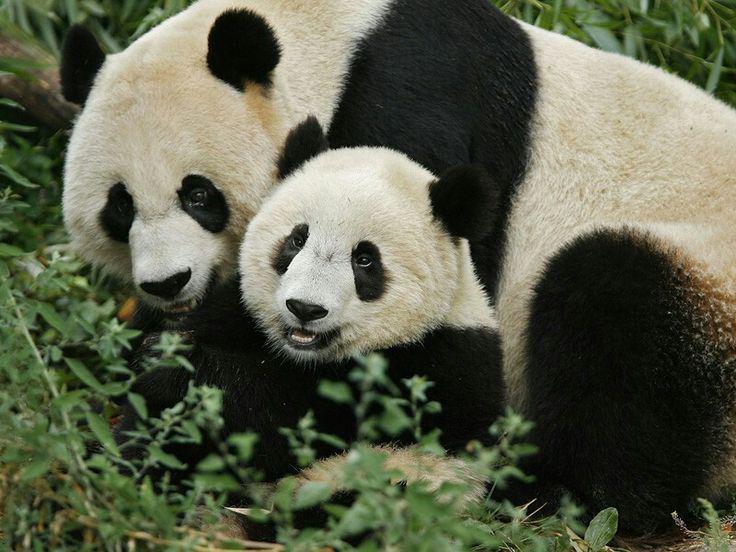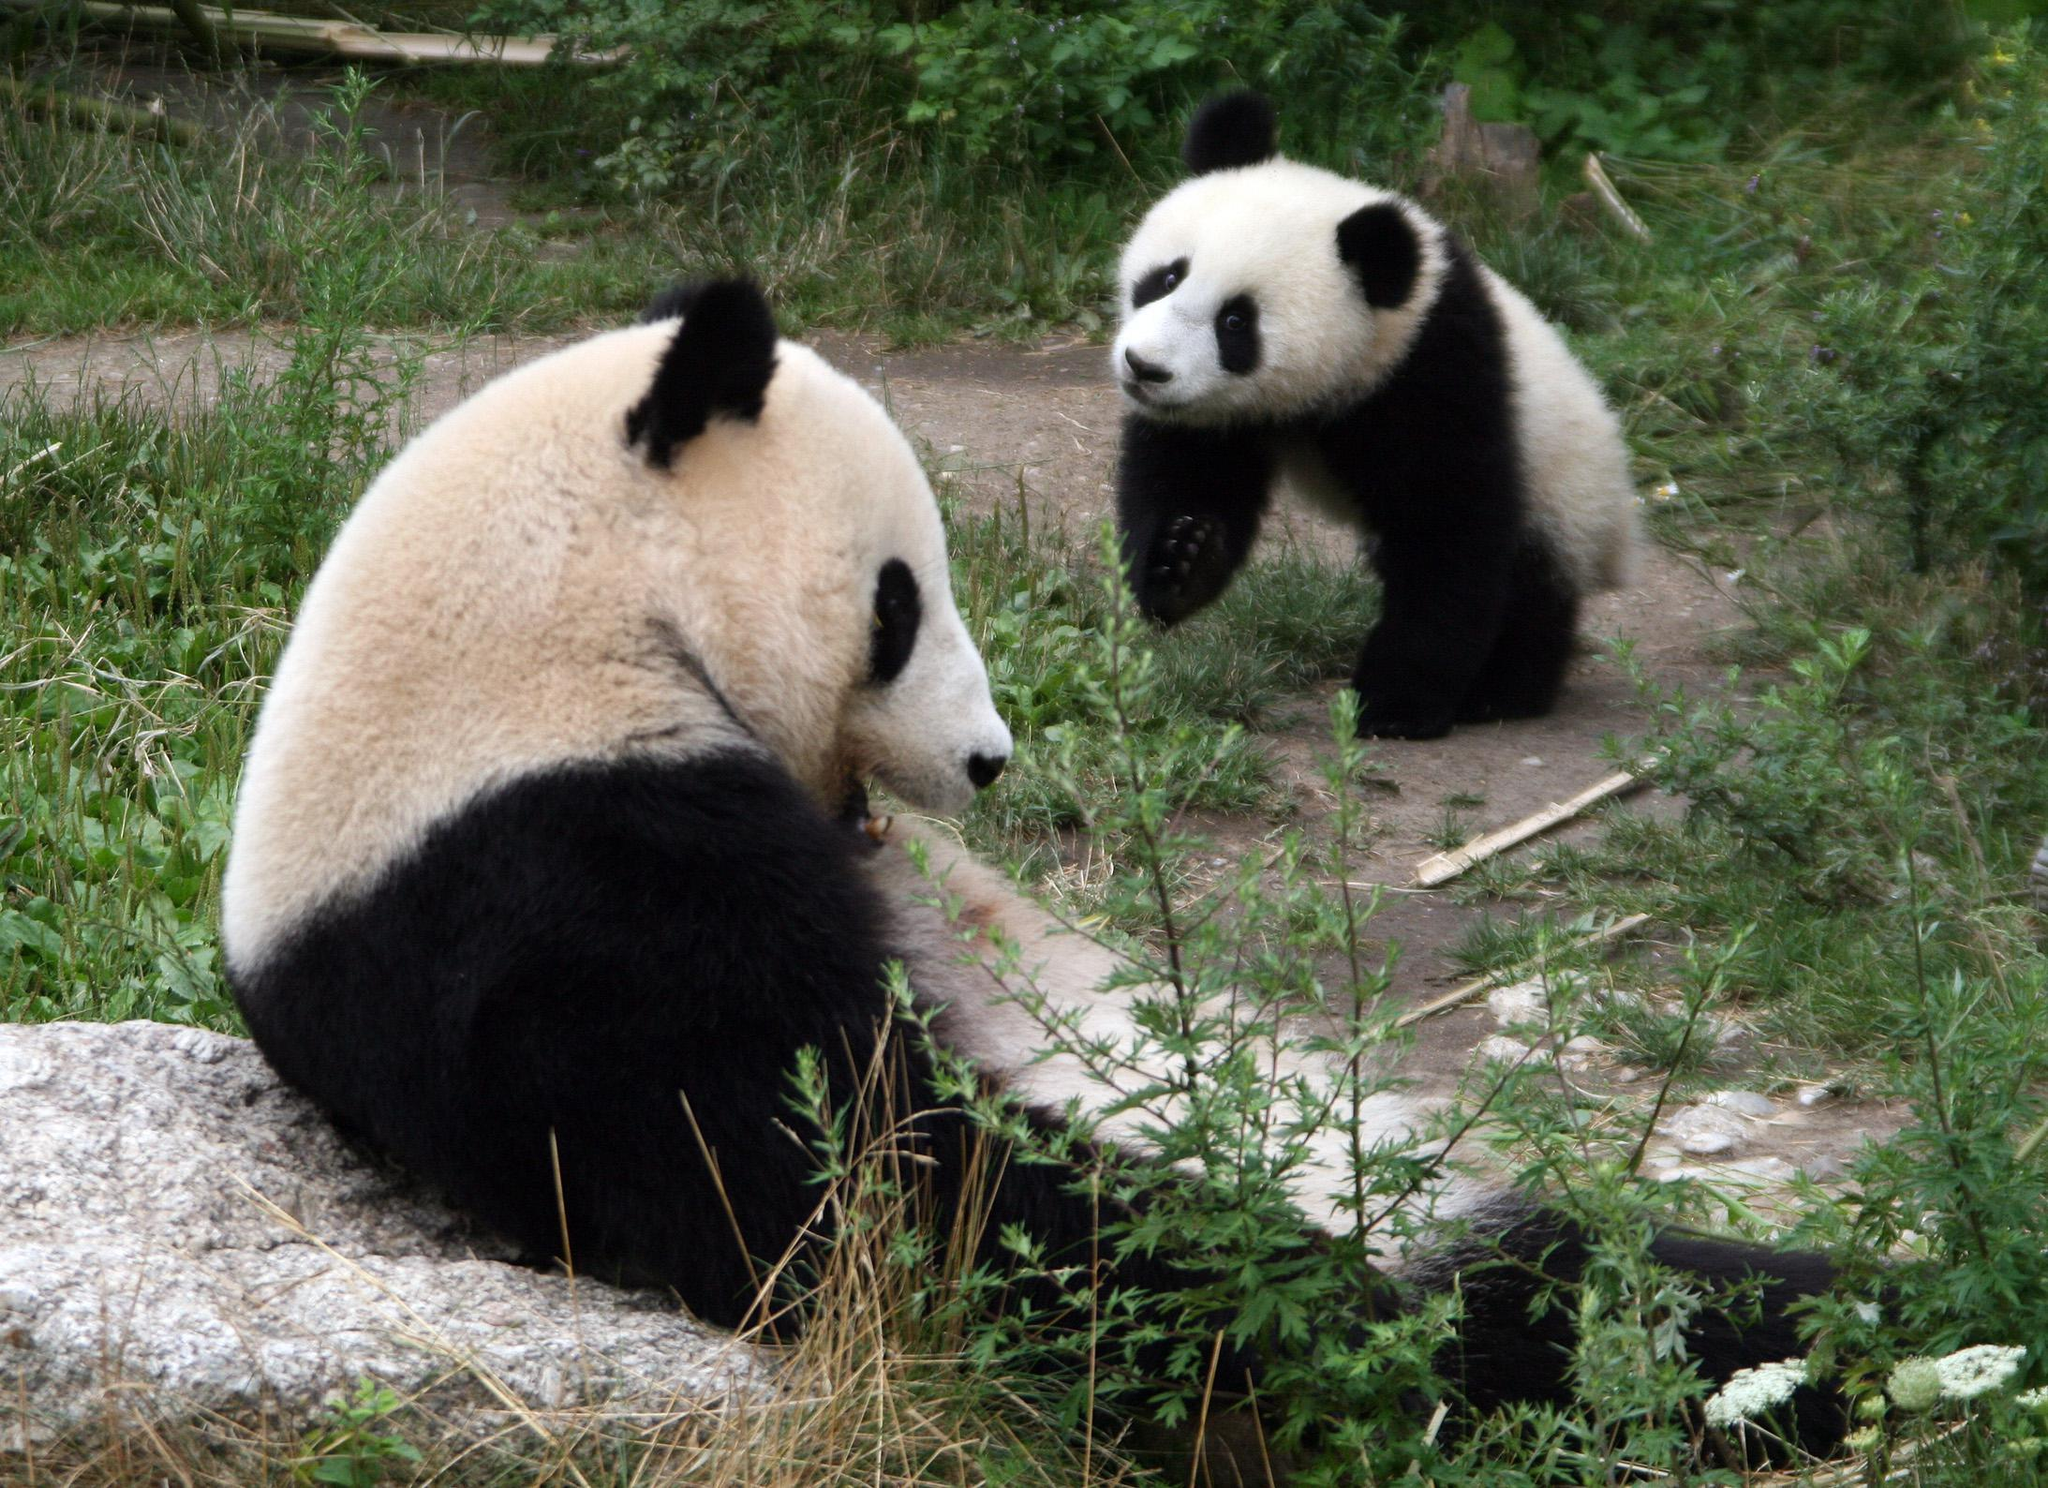The first image is the image on the left, the second image is the image on the right. Examine the images to the left and right. Is the description "There are four pandas and a large panda's head is next to a smaller panda's head in at least one of the images." accurate? Answer yes or no. Yes. The first image is the image on the left, the second image is the image on the right. Assess this claim about the two images: "there is exactly one panda in the image on the right.". Correct or not? Answer yes or no. No. 